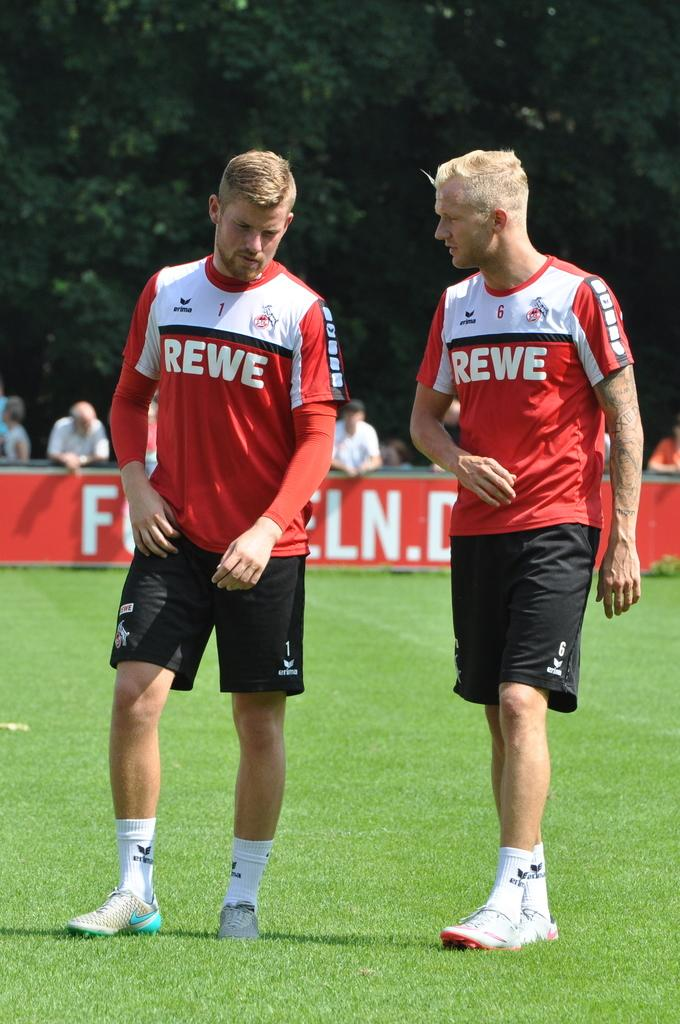Provide a one-sentence caption for the provided image. Two players for REWE walk and talk on the field together. 